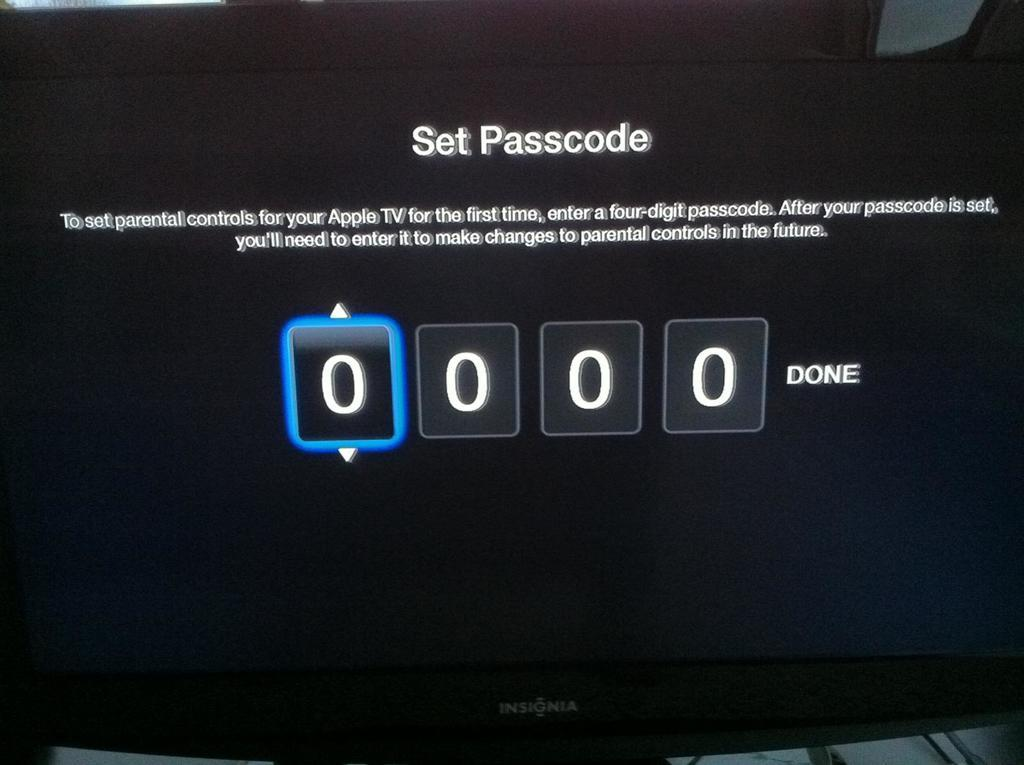<image>
Render a clear and concise summary of the photo. A screen displays the options for setting a passcode and is currently set on 0000. 